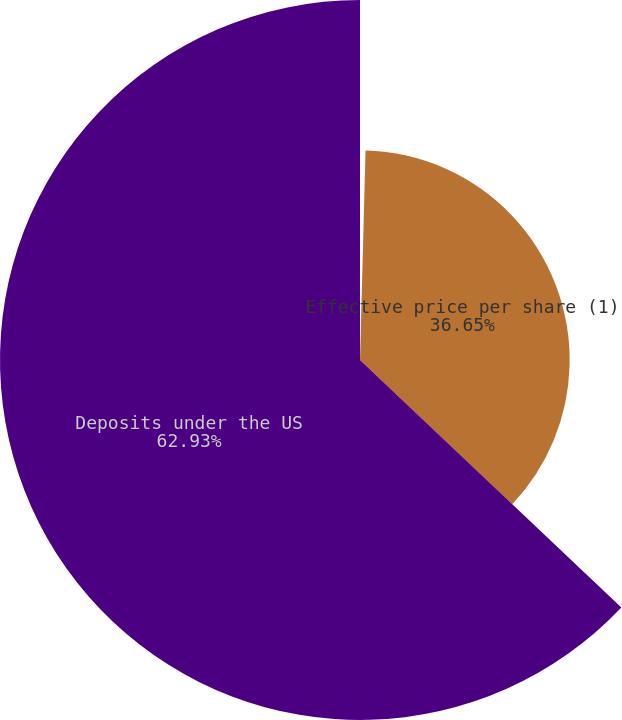<chart> <loc_0><loc_0><loc_500><loc_500><pie_chart><fcel>Reduction in equivalent number<fcel>Effective price per share (1)<fcel>Deposits under the US<nl><fcel>0.42%<fcel>36.65%<fcel>62.93%<nl></chart> 